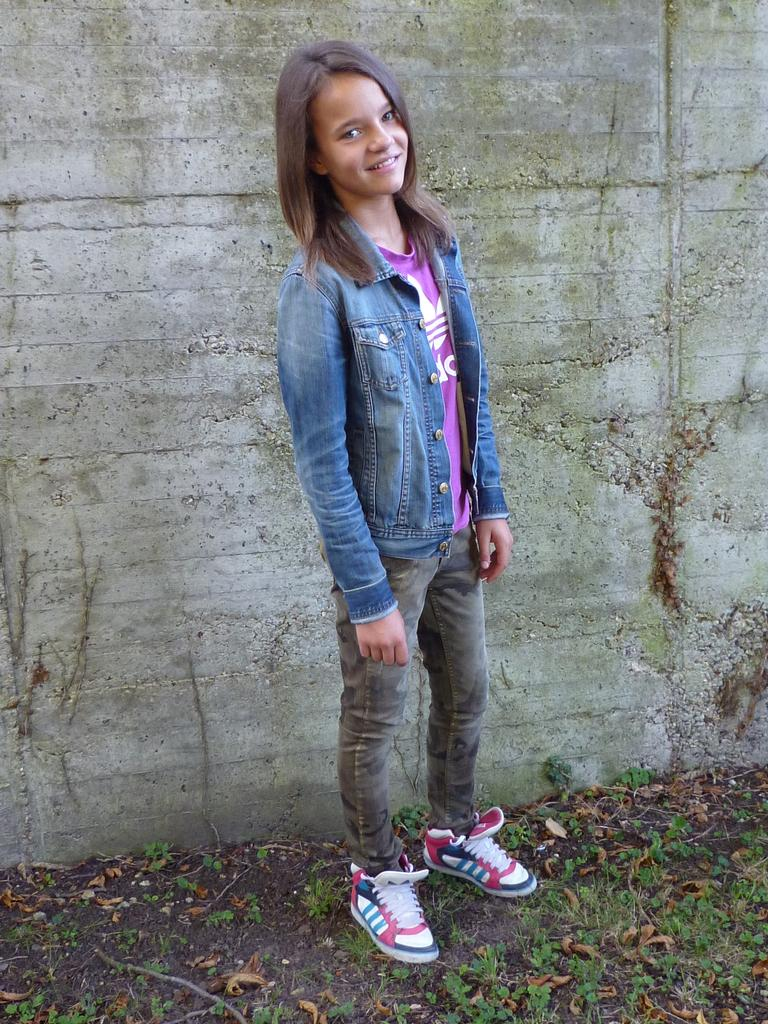Who is present in the image? There is a woman in the picture. What is the woman doing in the image? The woman is standing. What type of clothing is the woman wearing? The woman is wearing a jean jacket. What can be seen in the background of the image? There is a wall in the background of the picture. What type of wine is the woman holding in the image? There is no wine present in the image; the woman is not holding any wine. 